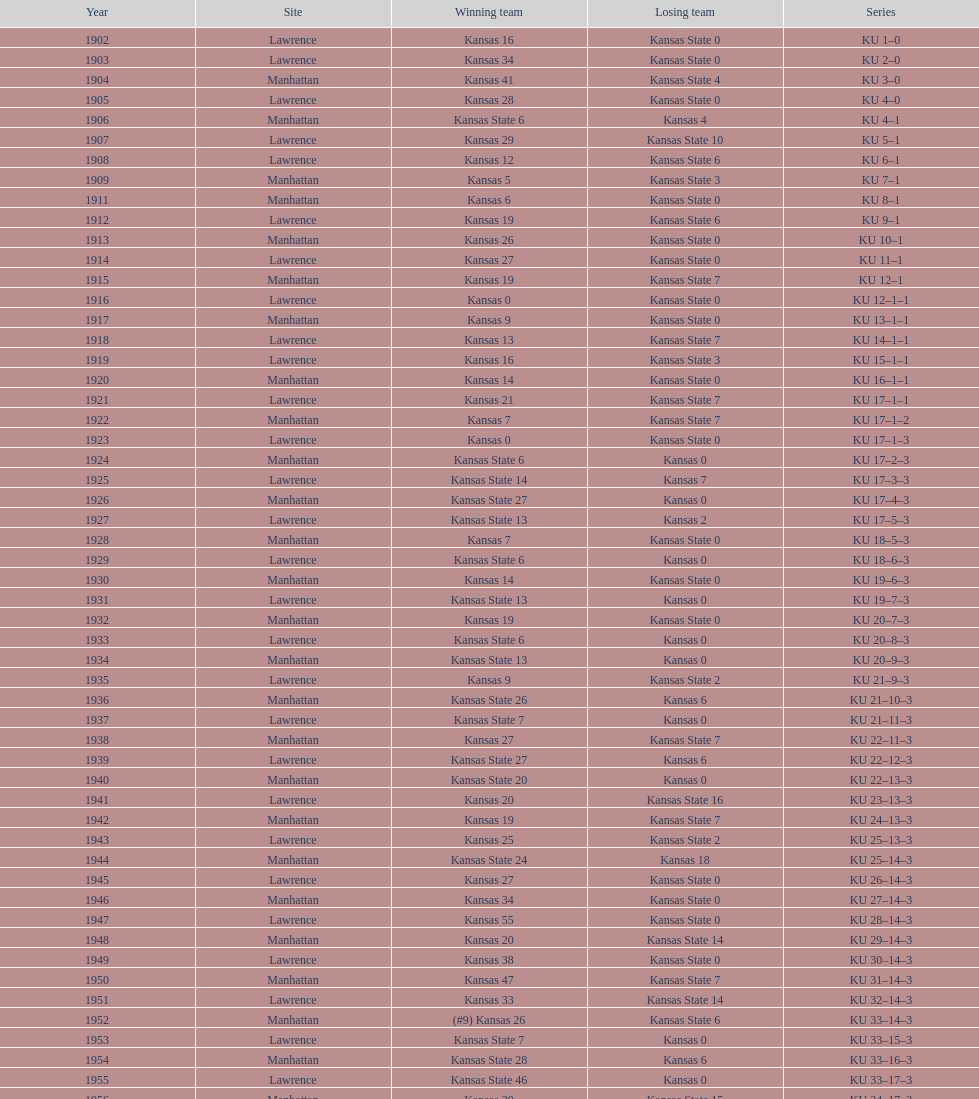Can you give me this table as a dict? {'header': ['Year', 'Site', 'Winning team', 'Losing team', 'Series'], 'rows': [['1902', 'Lawrence', 'Kansas 16', 'Kansas State 0', 'KU 1–0'], ['1903', 'Lawrence', 'Kansas 34', 'Kansas State 0', 'KU 2–0'], ['1904', 'Manhattan', 'Kansas 41', 'Kansas State 4', 'KU 3–0'], ['1905', 'Lawrence', 'Kansas 28', 'Kansas State 0', 'KU 4–0'], ['1906', 'Manhattan', 'Kansas State 6', 'Kansas 4', 'KU 4–1'], ['1907', 'Lawrence', 'Kansas 29', 'Kansas State 10', 'KU 5–1'], ['1908', 'Lawrence', 'Kansas 12', 'Kansas State 6', 'KU 6–1'], ['1909', 'Manhattan', 'Kansas 5', 'Kansas State 3', 'KU 7–1'], ['1911', 'Manhattan', 'Kansas 6', 'Kansas State 0', 'KU 8–1'], ['1912', 'Lawrence', 'Kansas 19', 'Kansas State 6', 'KU 9–1'], ['1913', 'Manhattan', 'Kansas 26', 'Kansas State 0', 'KU 10–1'], ['1914', 'Lawrence', 'Kansas 27', 'Kansas State 0', 'KU 11–1'], ['1915', 'Manhattan', 'Kansas 19', 'Kansas State 7', 'KU 12–1'], ['1916', 'Lawrence', 'Kansas 0', 'Kansas State 0', 'KU 12–1–1'], ['1917', 'Manhattan', 'Kansas 9', 'Kansas State 0', 'KU 13–1–1'], ['1918', 'Lawrence', 'Kansas 13', 'Kansas State 7', 'KU 14–1–1'], ['1919', 'Lawrence', 'Kansas 16', 'Kansas State 3', 'KU 15–1–1'], ['1920', 'Manhattan', 'Kansas 14', 'Kansas State 0', 'KU 16–1–1'], ['1921', 'Lawrence', 'Kansas 21', 'Kansas State 7', 'KU 17–1–1'], ['1922', 'Manhattan', 'Kansas 7', 'Kansas State 7', 'KU 17–1–2'], ['1923', 'Lawrence', 'Kansas 0', 'Kansas State 0', 'KU 17–1–3'], ['1924', 'Manhattan', 'Kansas State 6', 'Kansas 0', 'KU 17–2–3'], ['1925', 'Lawrence', 'Kansas State 14', 'Kansas 7', 'KU 17–3–3'], ['1926', 'Manhattan', 'Kansas State 27', 'Kansas 0', 'KU 17–4–3'], ['1927', 'Lawrence', 'Kansas State 13', 'Kansas 2', 'KU 17–5–3'], ['1928', 'Manhattan', 'Kansas 7', 'Kansas State 0', 'KU 18–5–3'], ['1929', 'Lawrence', 'Kansas State 6', 'Kansas 0', 'KU 18–6–3'], ['1930', 'Manhattan', 'Kansas 14', 'Kansas State 0', 'KU 19–6–3'], ['1931', 'Lawrence', 'Kansas State 13', 'Kansas 0', 'KU 19–7–3'], ['1932', 'Manhattan', 'Kansas 19', 'Kansas State 0', 'KU 20–7–3'], ['1933', 'Lawrence', 'Kansas State 6', 'Kansas 0', 'KU 20–8–3'], ['1934', 'Manhattan', 'Kansas State 13', 'Kansas 0', 'KU 20–9–3'], ['1935', 'Lawrence', 'Kansas 9', 'Kansas State 2', 'KU 21–9–3'], ['1936', 'Manhattan', 'Kansas State 26', 'Kansas 6', 'KU 21–10–3'], ['1937', 'Lawrence', 'Kansas State 7', 'Kansas 0', 'KU 21–11–3'], ['1938', 'Manhattan', 'Kansas 27', 'Kansas State 7', 'KU 22–11–3'], ['1939', 'Lawrence', 'Kansas State 27', 'Kansas 6', 'KU 22–12–3'], ['1940', 'Manhattan', 'Kansas State 20', 'Kansas 0', 'KU 22–13–3'], ['1941', 'Lawrence', 'Kansas 20', 'Kansas State 16', 'KU 23–13–3'], ['1942', 'Manhattan', 'Kansas 19', 'Kansas State 7', 'KU 24–13–3'], ['1943', 'Lawrence', 'Kansas 25', 'Kansas State 2', 'KU 25–13–3'], ['1944', 'Manhattan', 'Kansas State 24', 'Kansas 18', 'KU 25–14–3'], ['1945', 'Lawrence', 'Kansas 27', 'Kansas State 0', 'KU 26–14–3'], ['1946', 'Manhattan', 'Kansas 34', 'Kansas State 0', 'KU 27–14–3'], ['1947', 'Lawrence', 'Kansas 55', 'Kansas State 0', 'KU 28–14–3'], ['1948', 'Manhattan', 'Kansas 20', 'Kansas State 14', 'KU 29–14–3'], ['1949', 'Lawrence', 'Kansas 38', 'Kansas State 0', 'KU 30–14–3'], ['1950', 'Manhattan', 'Kansas 47', 'Kansas State 7', 'KU 31–14–3'], ['1951', 'Lawrence', 'Kansas 33', 'Kansas State 14', 'KU 32–14–3'], ['1952', 'Manhattan', '(#9) Kansas 26', 'Kansas State 6', 'KU 33–14–3'], ['1953', 'Lawrence', 'Kansas State 7', 'Kansas 0', 'KU 33–15–3'], ['1954', 'Manhattan', 'Kansas State 28', 'Kansas 6', 'KU 33–16–3'], ['1955', 'Lawrence', 'Kansas State 46', 'Kansas 0', 'KU 33–17–3'], ['1956', 'Manhattan', 'Kansas 20', 'Kansas State 15', 'KU 34–17–3'], ['1957', 'Lawrence', 'Kansas 13', 'Kansas State 7', 'KU 35–17–3'], ['1958', 'Manhattan', 'Kansas 21', 'Kansas State 12', 'KU 36–17–3'], ['1959', 'Lawrence', 'Kansas 33', 'Kansas State 14', 'KU 37–17–3'], ['1960', 'Manhattan', 'Kansas 41', 'Kansas State 0', 'KU 38–17–3'], ['1961', 'Lawrence', 'Kansas 34', 'Kansas State 0', 'KU 39–17–3'], ['1962', 'Manhattan', 'Kansas 38', 'Kansas State 0', 'KU 40–17–3'], ['1963', 'Lawrence', 'Kansas 34', 'Kansas State 0', 'KU 41–17–3'], ['1964', 'Manhattan', 'Kansas 7', 'Kansas State 0', 'KU 42–17–3'], ['1965', 'Lawrence', 'Kansas 34', 'Kansas State 0', 'KU 43–17–3'], ['1966', 'Manhattan', 'Kansas 3', 'Kansas State 3', 'KU 43–17–4'], ['1967', 'Lawrence', 'Kansas 17', 'Kansas State 16', 'KU 44–17–4'], ['1968', 'Manhattan', '(#7) Kansas 38', 'Kansas State 29', 'KU 45–17–4']]} What was the count of victories kansas state had in manhattan? 8. 